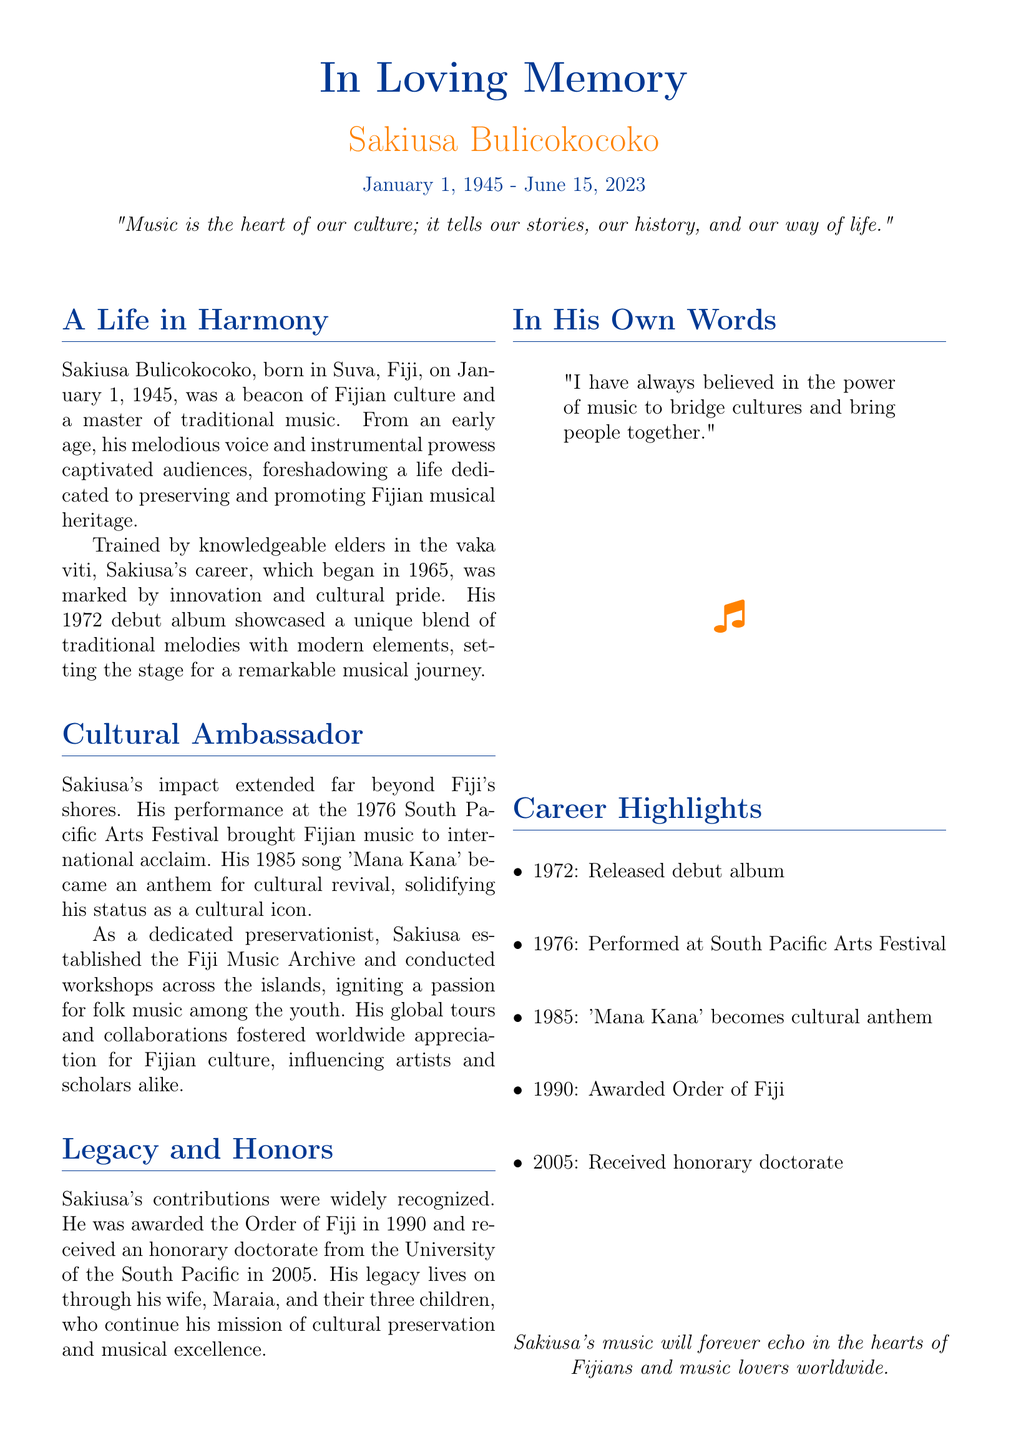What is the full name of the musician? The document mentions "Sakiusa Bulicokocoko" as the full name of the musician.
Answer: Sakiusa Bulicokocoko What was Sakiusa's date of birth? The document states that Sakiusa was born on January 1, 1945.
Answer: January 1, 1945 What song became an anthem for cultural revival? The obituary highlights the song 'Mana Kana' as an anthem for cultural revival.
Answer: Mana Kana When did Sakiusa perform at the South Pacific Arts Festival? The performance at the South Pacific Arts Festival occurred in 1976, as pointed out in the document.
Answer: 1976 What award did Sakiusa receive in 1990? The document notes that Sakiusa was awarded the Order of Fiji in 1990.
Answer: Order of Fiji What is described as the heart of Fijian culture? The document quotes, "Music is the heart of our culture," in reference to traditional music.
Answer: Music What institution awarded Sakiusa an honorary doctorate? The University of the South Pacific is mentioned as the institution that awarded him an honorary doctorate.
Answer: University of the South Pacific How many children did Sakiusa have? The document states that he had three children.
Answer: three What year did Sakiusa's career in music begin? According to the document, Sakiusa's musical career began in 1965.
Answer: 1965 